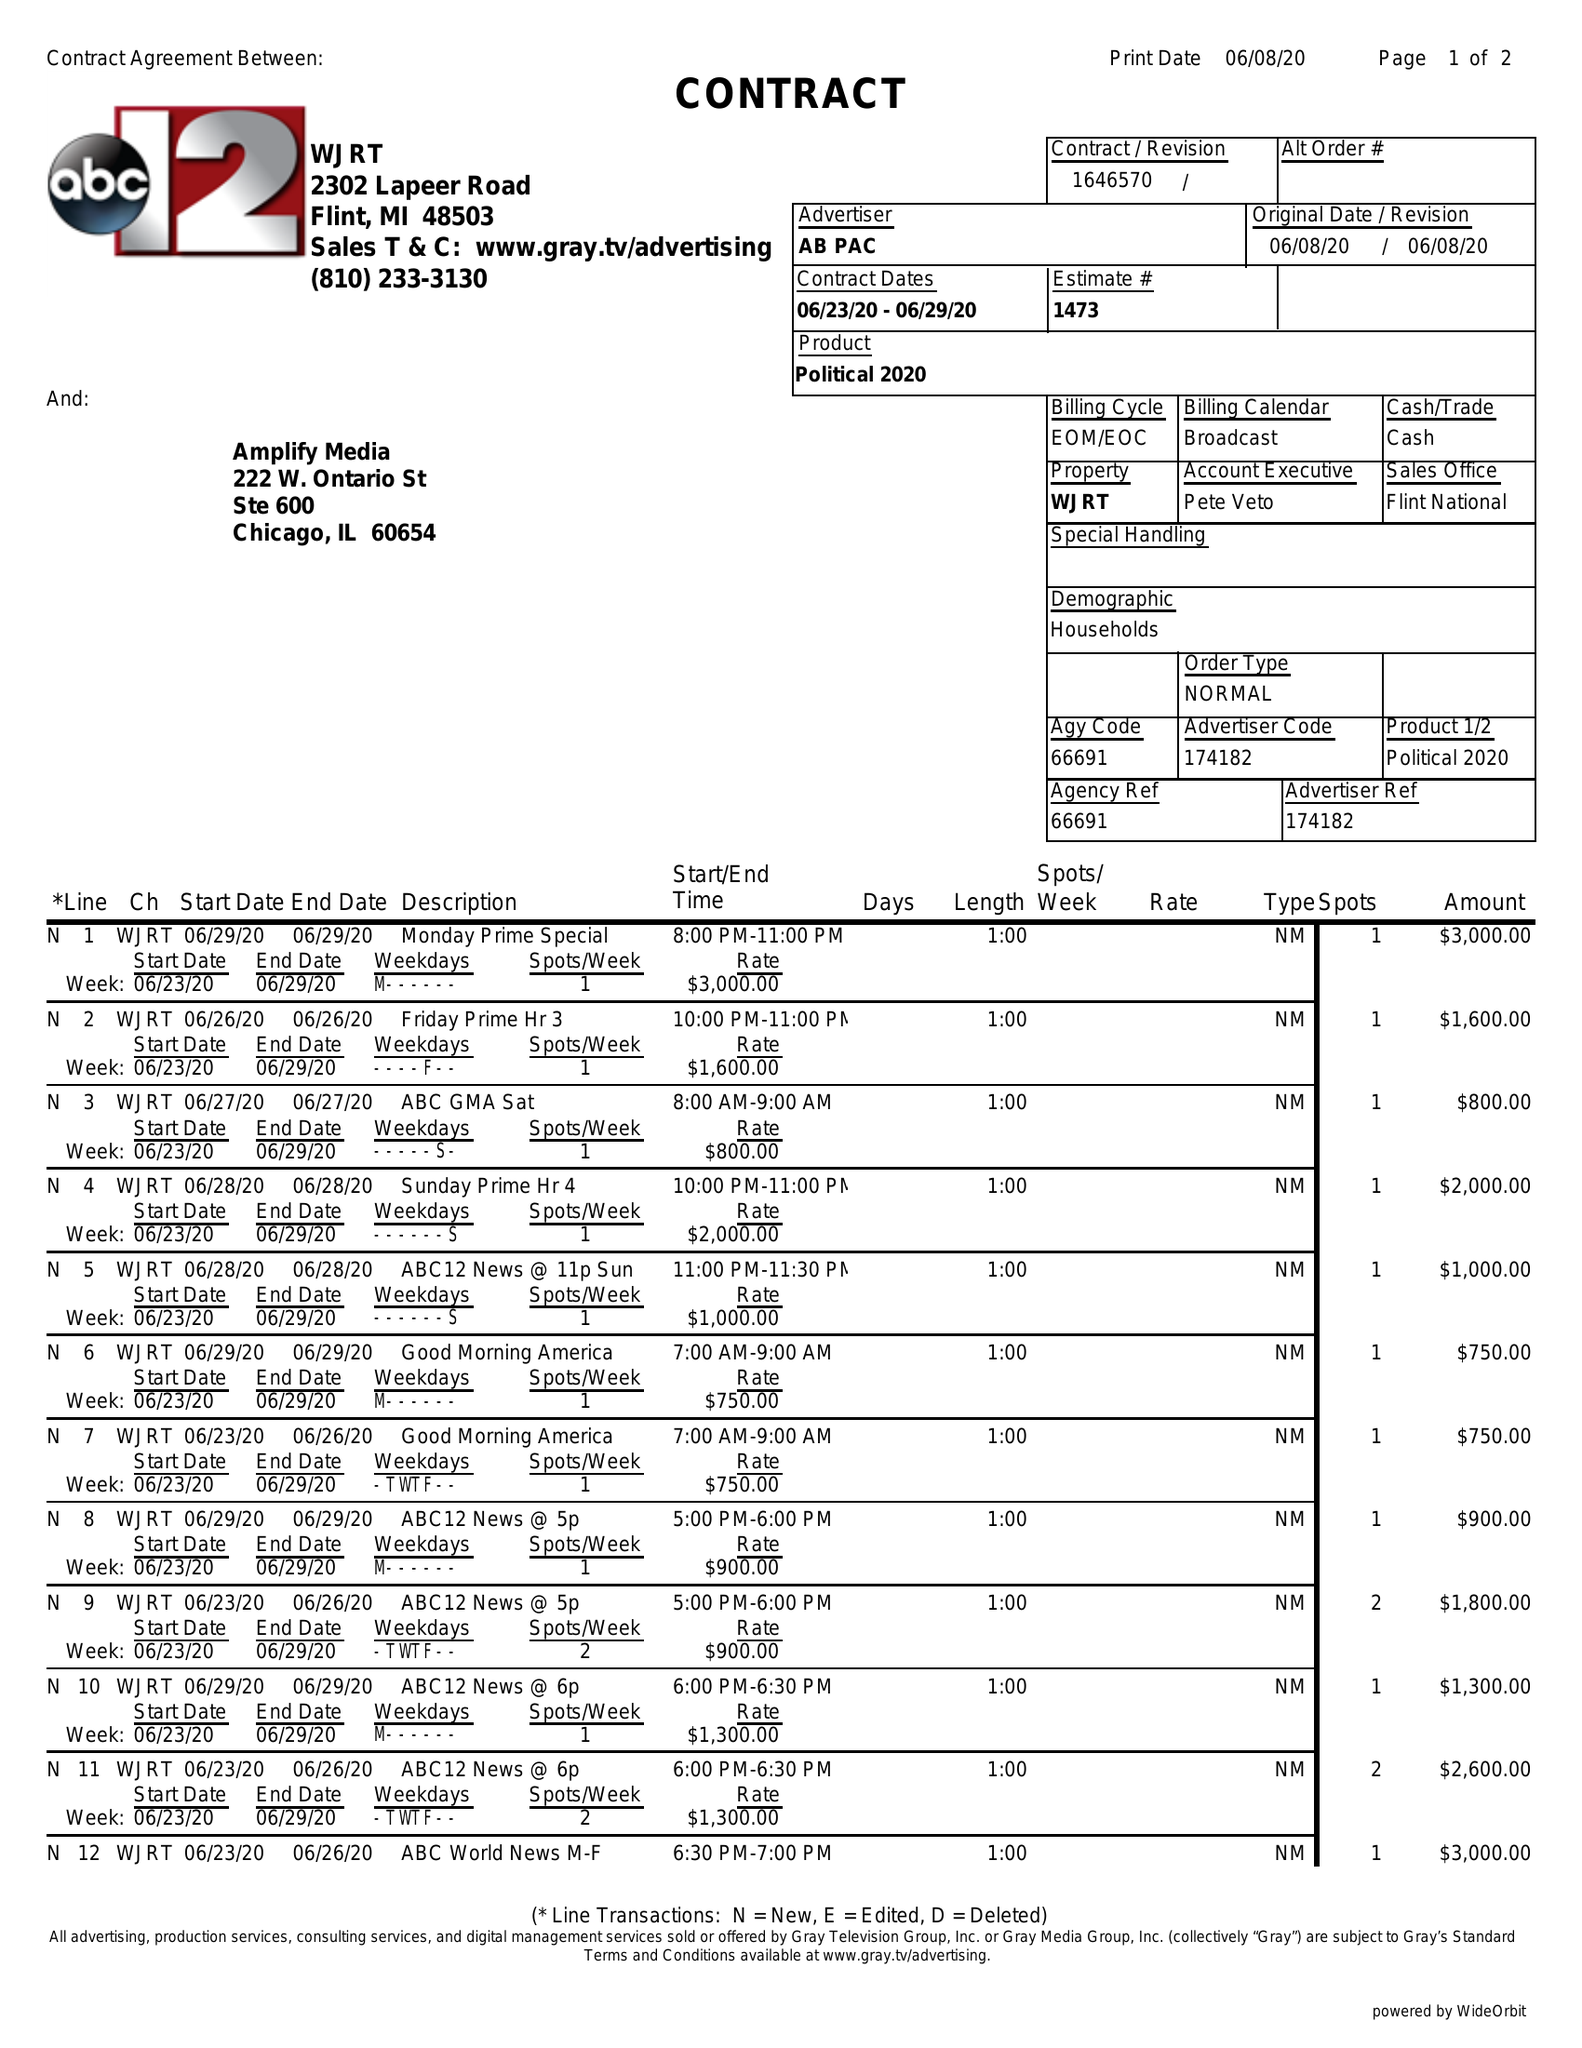What is the value for the gross_amount?
Answer the question using a single word or phrase. 21500.00 